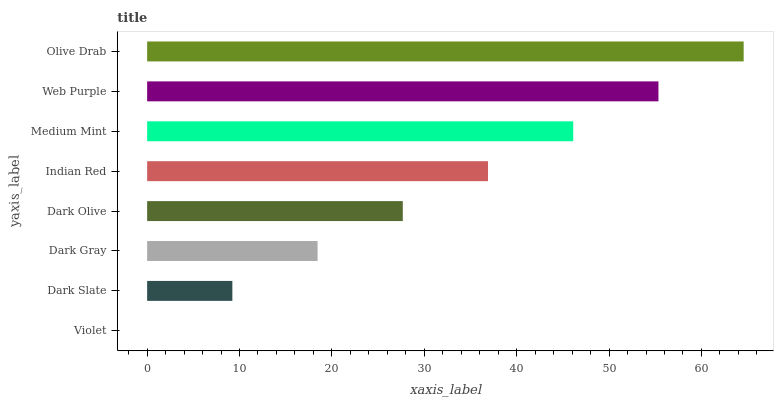Is Violet the minimum?
Answer yes or no. Yes. Is Olive Drab the maximum?
Answer yes or no. Yes. Is Dark Slate the minimum?
Answer yes or no. No. Is Dark Slate the maximum?
Answer yes or no. No. Is Dark Slate greater than Violet?
Answer yes or no. Yes. Is Violet less than Dark Slate?
Answer yes or no. Yes. Is Violet greater than Dark Slate?
Answer yes or no. No. Is Dark Slate less than Violet?
Answer yes or no. No. Is Indian Red the high median?
Answer yes or no. Yes. Is Dark Olive the low median?
Answer yes or no. Yes. Is Dark Gray the high median?
Answer yes or no. No. Is Olive Drab the low median?
Answer yes or no. No. 